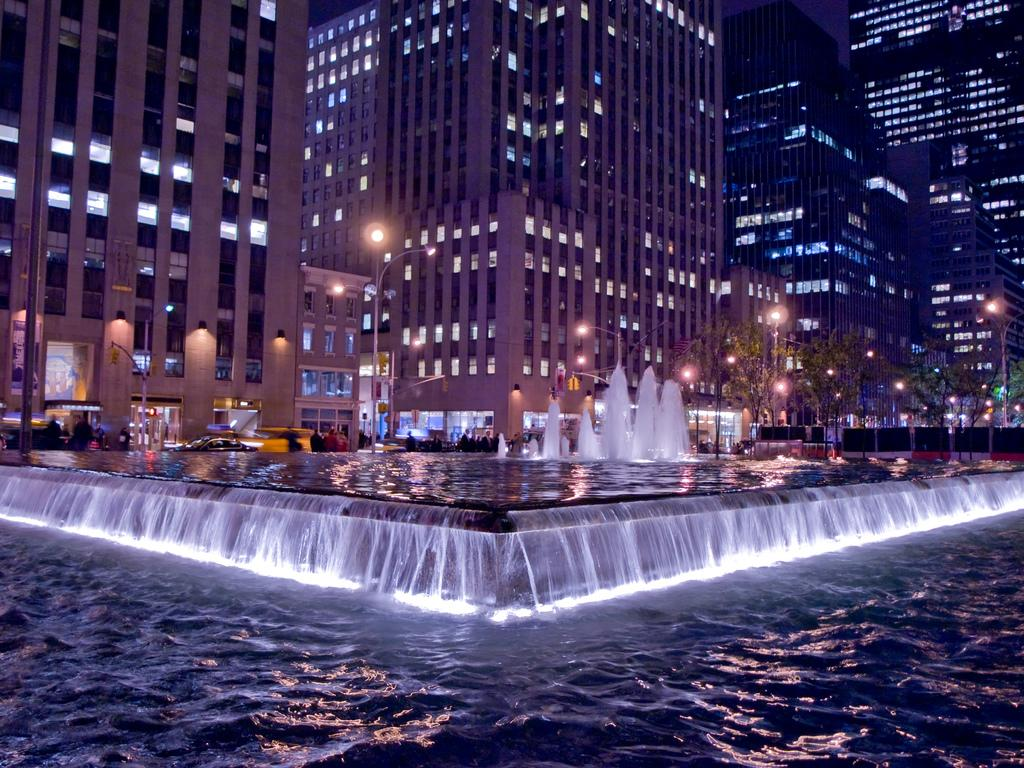What type of water feature is present in the image? There is a water fountain in the image. What can be seen in the background of the image? There are buildings visible in the image. What are the poles used for in the image? The poles are likely used to support the lights in the image. What type of illumination is present in the image? There are lights in the image. Are there any people in the image? Yes, there are people present in the image. What type of vase is being held by the person in the image? There is no vase present in the image. How does the person in the image grip the vase? Since there is no vase in the image, it is impossible to determine how the person would grip it. 